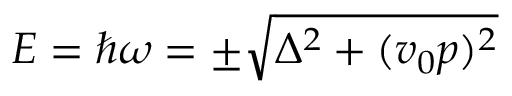Convert formula to latex. <formula><loc_0><loc_0><loc_500><loc_500>E = \hbar { \omega } = \pm \sqrt { \Delta ^ { 2 } + ( v _ { 0 } p ) ^ { 2 } }</formula> 